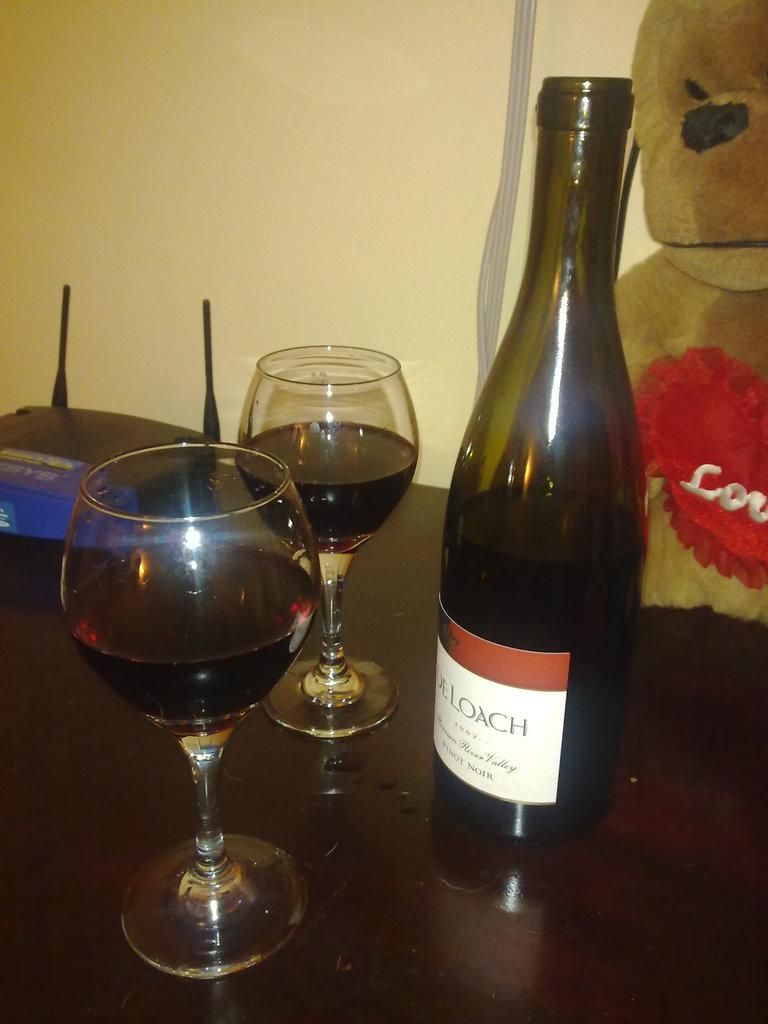What type of containers are present in the image? There are glasses with a drink in the image. What other object can be seen related to the drink? There is a bottle in the image. What additional object is present in the image? There is a device in the image. What type of toy is in the image? There is a teddy bear in the image. Where are all these objects placed? All of these objects are placed on a table. What can be seen in the background of the image? There is a wall visible in the background of the image. Can you describe the fog in the image? There is no fog present in the image. What type of cannon is visible in the image? There is no cannon present in the image. 